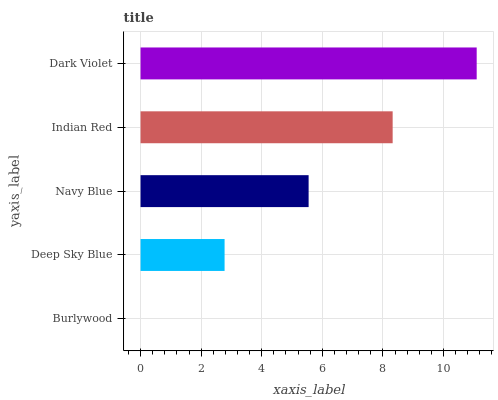Is Burlywood the minimum?
Answer yes or no. Yes. Is Dark Violet the maximum?
Answer yes or no. Yes. Is Deep Sky Blue the minimum?
Answer yes or no. No. Is Deep Sky Blue the maximum?
Answer yes or no. No. Is Deep Sky Blue greater than Burlywood?
Answer yes or no. Yes. Is Burlywood less than Deep Sky Blue?
Answer yes or no. Yes. Is Burlywood greater than Deep Sky Blue?
Answer yes or no. No. Is Deep Sky Blue less than Burlywood?
Answer yes or no. No. Is Navy Blue the high median?
Answer yes or no. Yes. Is Navy Blue the low median?
Answer yes or no. Yes. Is Indian Red the high median?
Answer yes or no. No. Is Burlywood the low median?
Answer yes or no. No. 